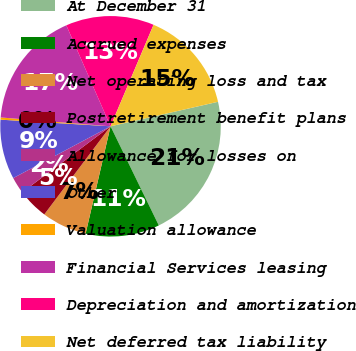Convert chart. <chart><loc_0><loc_0><loc_500><loc_500><pie_chart><fcel>At December 31<fcel>Accrued expenses<fcel>Net operating loss and tax<fcel>Postretirement benefit plans<fcel>Allowance for losses on<fcel>Other<fcel>Valuation allowance<fcel>Financial Services leasing<fcel>Depreciation and amortization<fcel>Net deferred tax liability<nl><fcel>21.36%<fcel>10.84%<fcel>6.63%<fcel>4.53%<fcel>2.43%<fcel>8.74%<fcel>0.32%<fcel>17.15%<fcel>12.95%<fcel>15.05%<nl></chart> 